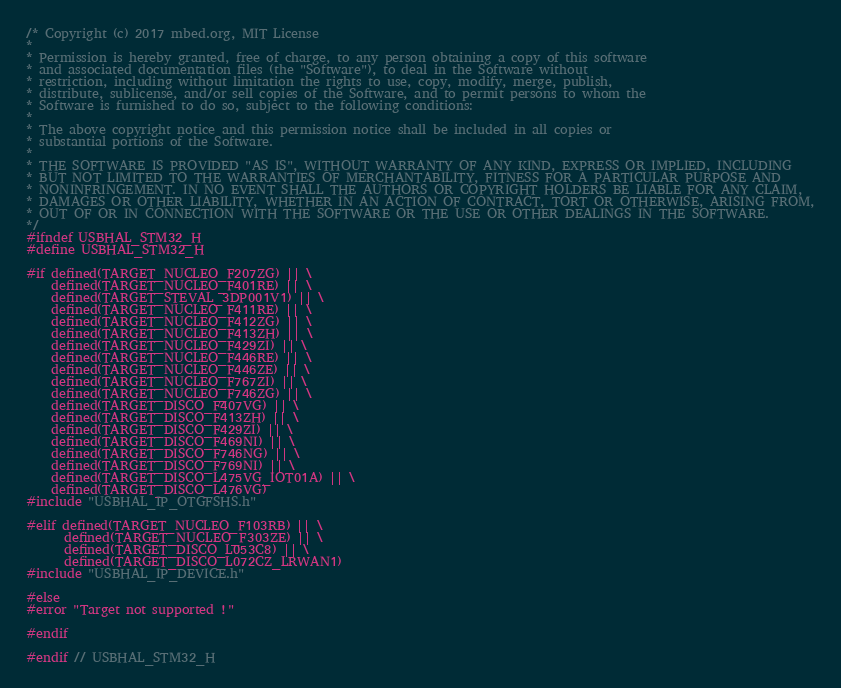<code> <loc_0><loc_0><loc_500><loc_500><_C_>/* Copyright (c) 2017 mbed.org, MIT License
*
* Permission is hereby granted, free of charge, to any person obtaining a copy of this software
* and associated documentation files (the "Software"), to deal in the Software without
* restriction, including without limitation the rights to use, copy, modify, merge, publish,
* distribute, sublicense, and/or sell copies of the Software, and to permit persons to whom the
* Software is furnished to do so, subject to the following conditions:
*
* The above copyright notice and this permission notice shall be included in all copies or
* substantial portions of the Software.
*
* THE SOFTWARE IS PROVIDED "AS IS", WITHOUT WARRANTY OF ANY KIND, EXPRESS OR IMPLIED, INCLUDING
* BUT NOT LIMITED TO THE WARRANTIES OF MERCHANTABILITY, FITNESS FOR A PARTICULAR PURPOSE AND
* NONINFRINGEMENT. IN NO EVENT SHALL THE AUTHORS OR COPYRIGHT HOLDERS BE LIABLE FOR ANY CLAIM,
* DAMAGES OR OTHER LIABILITY, WHETHER IN AN ACTION OF CONTRACT, TORT OR OTHERWISE, ARISING FROM,
* OUT OF OR IN CONNECTION WITH THE SOFTWARE OR THE USE OR OTHER DEALINGS IN THE SOFTWARE.
*/
#ifndef USBHAL_STM32_H
#define USBHAL_STM32_H

#if defined(TARGET_NUCLEO_F207ZG) || \
    defined(TARGET_NUCLEO_F401RE) || \
    defined(TARGET_STEVAL_3DP001V1) || \
    defined(TARGET_NUCLEO_F411RE) || \
    defined(TARGET_NUCLEO_F412ZG) || \
    defined(TARGET_NUCLEO_F413ZH) || \
    defined(TARGET_NUCLEO_F429ZI) || \
    defined(TARGET_NUCLEO_F446RE) || \
    defined(TARGET_NUCLEO_F446ZE) || \
    defined(TARGET_NUCLEO_F767ZI) || \
    defined(TARGET_NUCLEO_F746ZG) || \
    defined(TARGET_DISCO_F407VG) || \
    defined(TARGET_DISCO_F413ZH) || \
    defined(TARGET_DISCO_F429ZI) || \
    defined(TARGET_DISCO_F469NI) || \
    defined(TARGET_DISCO_F746NG) || \
    defined(TARGET_DISCO_F769NI) || \
    defined(TARGET_DISCO_L475VG_IOT01A) || \
    defined(TARGET_DISCO_L476VG)
#include "USBHAL_IP_OTGFSHS.h"

#elif defined(TARGET_NUCLEO_F103RB) || \
      defined(TARGET_NUCLEO_F303ZE) || \
      defined(TARGET_DISCO_L053C8) || \
      defined(TARGET_DISCO_L072CZ_LRWAN1)
#include "USBHAL_IP_DEVICE.h"

#else
#error "Target not supported !"

#endif

#endif // USBHAL_STM32_H
</code> 